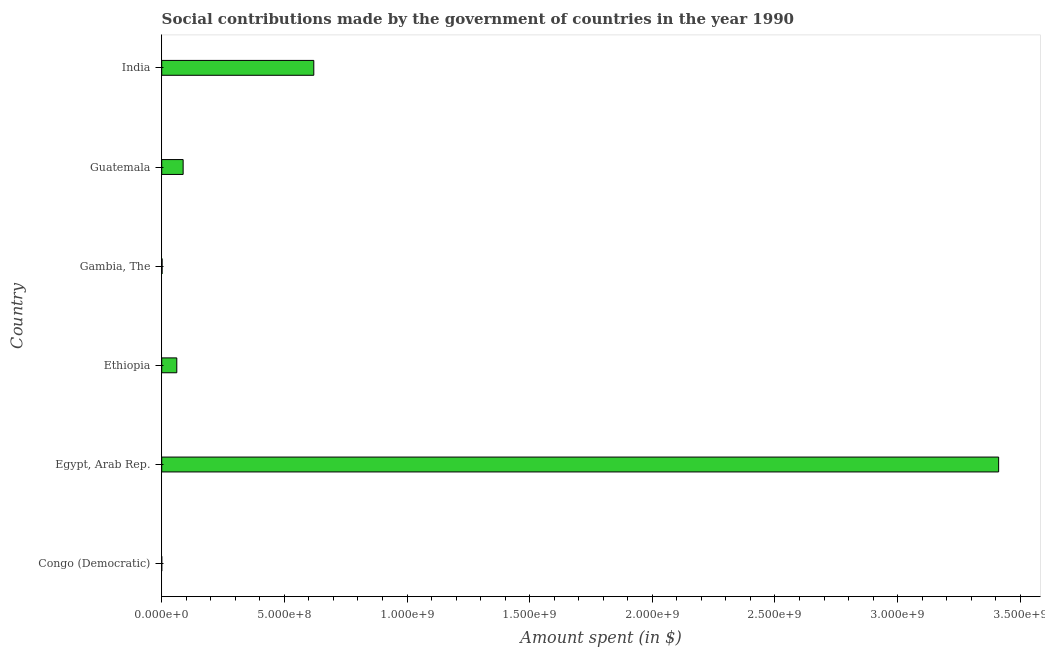Does the graph contain any zero values?
Ensure brevity in your answer.  No. What is the title of the graph?
Offer a very short reply. Social contributions made by the government of countries in the year 1990. What is the label or title of the X-axis?
Provide a short and direct response. Amount spent (in $). What is the label or title of the Y-axis?
Provide a short and direct response. Country. What is the amount spent in making social contributions in Egypt, Arab Rep.?
Make the answer very short. 3.41e+09. Across all countries, what is the maximum amount spent in making social contributions?
Your answer should be very brief. 3.41e+09. Across all countries, what is the minimum amount spent in making social contributions?
Your response must be concise. 0.03. In which country was the amount spent in making social contributions maximum?
Ensure brevity in your answer.  Egypt, Arab Rep. In which country was the amount spent in making social contributions minimum?
Your answer should be very brief. Congo (Democratic). What is the sum of the amount spent in making social contributions?
Offer a very short reply. 4.18e+09. What is the difference between the amount spent in making social contributions in Ethiopia and Guatemala?
Offer a terse response. -2.58e+07. What is the average amount spent in making social contributions per country?
Provide a short and direct response. 6.97e+08. What is the median amount spent in making social contributions?
Provide a short and direct response. 7.44e+07. In how many countries, is the amount spent in making social contributions greater than 2000000000 $?
Make the answer very short. 1. Is the difference between the amount spent in making social contributions in Congo (Democratic) and Egypt, Arab Rep. greater than the difference between any two countries?
Provide a short and direct response. Yes. What is the difference between the highest and the second highest amount spent in making social contributions?
Make the answer very short. 2.79e+09. Is the sum of the amount spent in making social contributions in Egypt, Arab Rep. and Ethiopia greater than the maximum amount spent in making social contributions across all countries?
Offer a terse response. Yes. What is the difference between the highest and the lowest amount spent in making social contributions?
Offer a terse response. 3.41e+09. In how many countries, is the amount spent in making social contributions greater than the average amount spent in making social contributions taken over all countries?
Offer a terse response. 1. Are all the bars in the graph horizontal?
Give a very brief answer. Yes. What is the Amount spent (in $) of Congo (Democratic)?
Provide a short and direct response. 0.03. What is the Amount spent (in $) in Egypt, Arab Rep.?
Keep it short and to the point. 3.41e+09. What is the Amount spent (in $) in Ethiopia?
Give a very brief answer. 6.15e+07. What is the Amount spent (in $) of Gambia, The?
Make the answer very short. 1.53e+06. What is the Amount spent (in $) in Guatemala?
Provide a short and direct response. 8.73e+07. What is the Amount spent (in $) of India?
Keep it short and to the point. 6.20e+08. What is the difference between the Amount spent (in $) in Congo (Democratic) and Egypt, Arab Rep.?
Offer a very short reply. -3.41e+09. What is the difference between the Amount spent (in $) in Congo (Democratic) and Ethiopia?
Your response must be concise. -6.15e+07. What is the difference between the Amount spent (in $) in Congo (Democratic) and Gambia, The?
Give a very brief answer. -1.53e+06. What is the difference between the Amount spent (in $) in Congo (Democratic) and Guatemala?
Provide a succinct answer. -8.73e+07. What is the difference between the Amount spent (in $) in Congo (Democratic) and India?
Provide a succinct answer. -6.20e+08. What is the difference between the Amount spent (in $) in Egypt, Arab Rep. and Ethiopia?
Ensure brevity in your answer.  3.35e+09. What is the difference between the Amount spent (in $) in Egypt, Arab Rep. and Gambia, The?
Offer a terse response. 3.41e+09. What is the difference between the Amount spent (in $) in Egypt, Arab Rep. and Guatemala?
Offer a terse response. 3.32e+09. What is the difference between the Amount spent (in $) in Egypt, Arab Rep. and India?
Keep it short and to the point. 2.79e+09. What is the difference between the Amount spent (in $) in Ethiopia and Gambia, The?
Your answer should be very brief. 6.00e+07. What is the difference between the Amount spent (in $) in Ethiopia and Guatemala?
Your response must be concise. -2.58e+07. What is the difference between the Amount spent (in $) in Ethiopia and India?
Offer a terse response. -5.58e+08. What is the difference between the Amount spent (in $) in Gambia, The and Guatemala?
Give a very brief answer. -8.58e+07. What is the difference between the Amount spent (in $) in Gambia, The and India?
Make the answer very short. -6.18e+08. What is the difference between the Amount spent (in $) in Guatemala and India?
Offer a terse response. -5.33e+08. What is the ratio of the Amount spent (in $) in Congo (Democratic) to that in Gambia, The?
Ensure brevity in your answer.  0. What is the ratio of the Amount spent (in $) in Congo (Democratic) to that in India?
Provide a succinct answer. 0. What is the ratio of the Amount spent (in $) in Egypt, Arab Rep. to that in Ethiopia?
Your answer should be very brief. 55.48. What is the ratio of the Amount spent (in $) in Egypt, Arab Rep. to that in Gambia, The?
Keep it short and to the point. 2230.07. What is the ratio of the Amount spent (in $) in Egypt, Arab Rep. to that in Guatemala?
Provide a succinct answer. 39.07. What is the ratio of the Amount spent (in $) in Egypt, Arab Rep. to that in India?
Ensure brevity in your answer.  5.5. What is the ratio of the Amount spent (in $) in Ethiopia to that in Gambia, The?
Your answer should be very brief. 40.2. What is the ratio of the Amount spent (in $) in Ethiopia to that in Guatemala?
Your answer should be compact. 0.7. What is the ratio of the Amount spent (in $) in Ethiopia to that in India?
Keep it short and to the point. 0.1. What is the ratio of the Amount spent (in $) in Gambia, The to that in Guatemala?
Your response must be concise. 0.02. What is the ratio of the Amount spent (in $) in Gambia, The to that in India?
Your response must be concise. 0. What is the ratio of the Amount spent (in $) in Guatemala to that in India?
Your answer should be very brief. 0.14. 